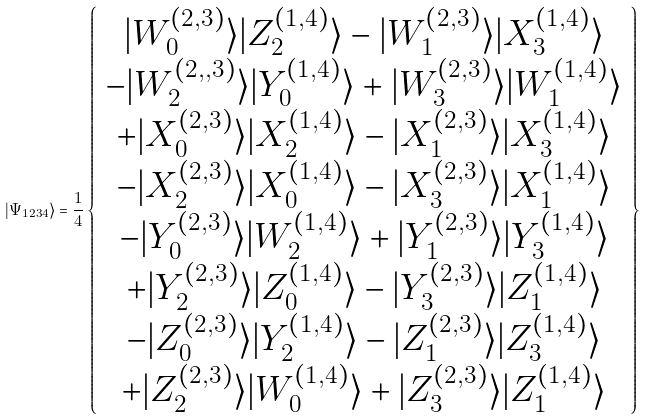Convert formula to latex. <formula><loc_0><loc_0><loc_500><loc_500>| \Psi _ { 1 2 3 4 } \rangle = \frac { 1 } { 4 } \left \{ \begin{array} { c } | W _ { 0 } ^ { \left ( 2 , 3 \right ) } \rangle | Z _ { 2 } ^ { \left ( 1 , 4 \right ) } \rangle - | W _ { 1 } ^ { \left ( 2 , 3 \right ) } \rangle | X _ { 3 } ^ { \left ( 1 , 4 \right ) } \rangle \\ - | W _ { 2 } ^ { \left ( 2 , , 3 \right ) } \rangle | Y _ { 0 } ^ { \left ( 1 , 4 \right ) } \rangle + | W _ { 3 } ^ { \left ( 2 , 3 \right ) } \rangle | W _ { 1 } ^ { \left ( 1 , 4 \right ) } \rangle \\ + | X _ { 0 } ^ { \left ( 2 , 3 \right ) } \rangle | X _ { 2 } ^ { \left ( 1 , 4 \right ) } \rangle - | X _ { 1 } ^ { \left ( 2 , 3 \right ) } \rangle | X _ { 3 } ^ { \left ( 1 , 4 \right ) } \rangle \\ - | X _ { 2 } ^ { \left ( 2 , 3 \right ) } \rangle | X _ { 0 } ^ { \left ( 1 , 4 \right ) } \rangle - | X _ { 3 } ^ { \left ( 2 , 3 \right ) } \rangle | X _ { 1 } ^ { \left ( 1 , 4 \right ) } \rangle \\ - | Y _ { 0 } ^ { \left ( 2 , 3 \right ) } \rangle | W _ { 2 } ^ { \left ( 1 , 4 \right ) } \rangle + | Y _ { 1 } ^ { \left ( 2 , 3 \right ) } \rangle | Y _ { 3 } ^ { \left ( 1 , 4 \right ) } \rangle \\ + | Y _ { 2 } ^ { \left ( 2 , 3 \right ) } \rangle | Z _ { 0 } ^ { \left ( 1 , 4 \right ) } \rangle - | Y _ { 3 } ^ { \left ( 2 , 3 \right ) } \rangle | Z _ { 1 } ^ { \left ( 1 , 4 \right ) } \rangle \\ - | Z _ { 0 } ^ { \left ( 2 , 3 \right ) } \rangle | Y _ { 2 } ^ { \left ( 1 , 4 \right ) } \rangle - | Z _ { 1 } ^ { \left ( 2 , 3 \right ) } \rangle | Z _ { 3 } ^ { \left ( 1 , 4 \right ) } \rangle \\ + | Z _ { 2 } ^ { \left ( 2 , 3 \right ) } \rangle | W _ { 0 } ^ { \left ( 1 , 4 \right ) } \rangle + | Z _ { 3 } ^ { \left ( 2 , 3 \right ) } \rangle | Z _ { 1 } ^ { \left ( 1 , 4 \right ) } \rangle \end{array} \right \}</formula> 